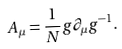Convert formula to latex. <formula><loc_0><loc_0><loc_500><loc_500>A _ { \mu } = \frac { 1 } { N } g \partial _ { \mu } g ^ { - 1 } .</formula> 